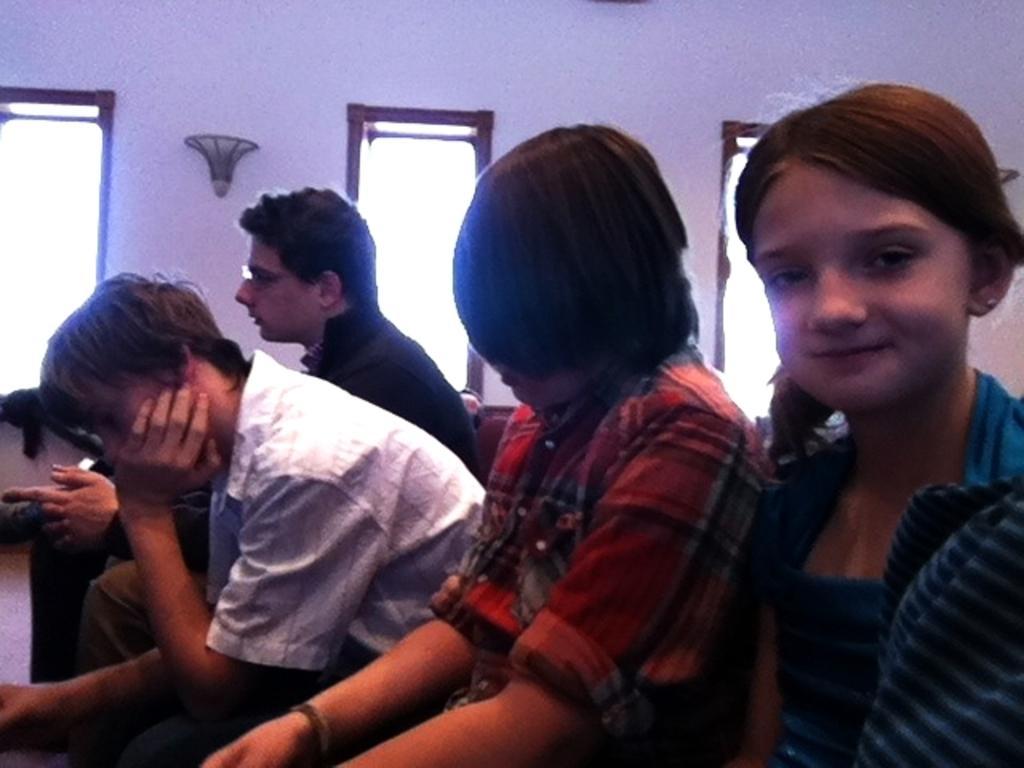Please provide a concise description of this image. In this image, we can see four persons are sitting. On the right side of the image, we can see a girl is smiling. In the background, we can see wall, showpieces and few objects. 